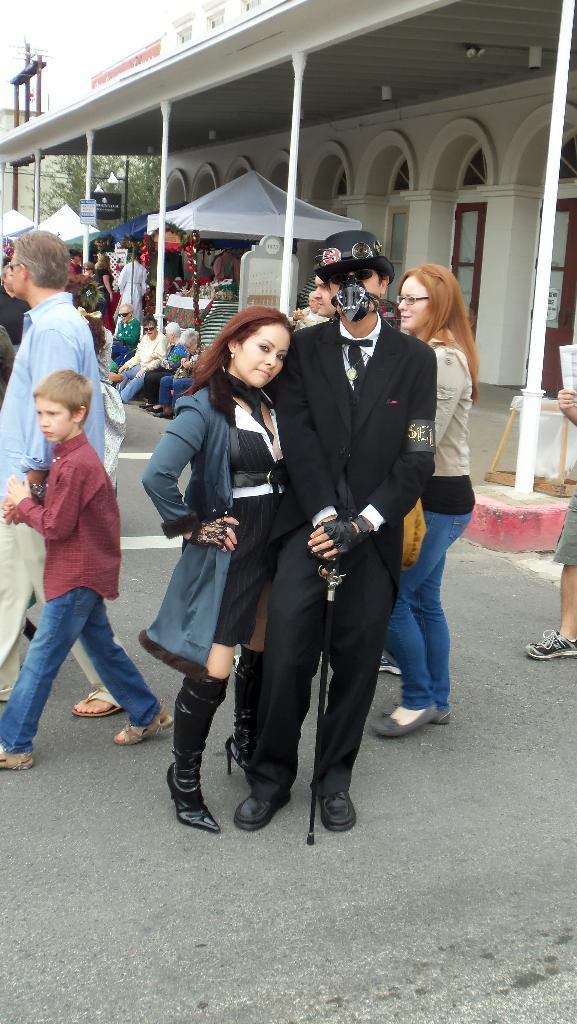In one or two sentences, can you explain what this image depicts? In this image we can see a group of people standing on the ground. one person is wearing mask and hat is holding a stick in his hand. On the left side of the image we can see some persons sitting. In the background, we can see some tents, objects placed on the table, sign board with some text, building with poles, arches, trees and the sky. 